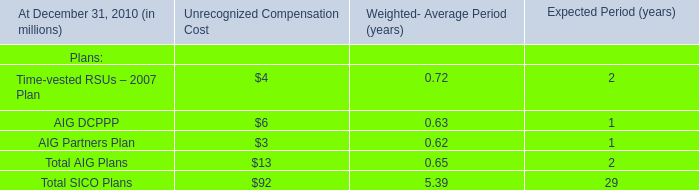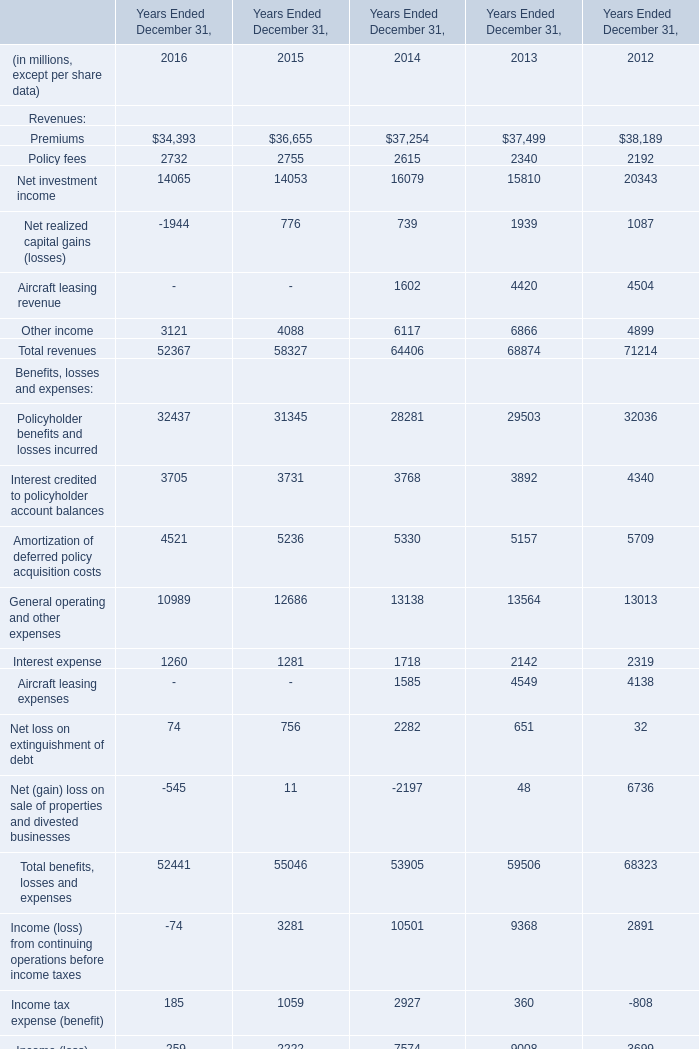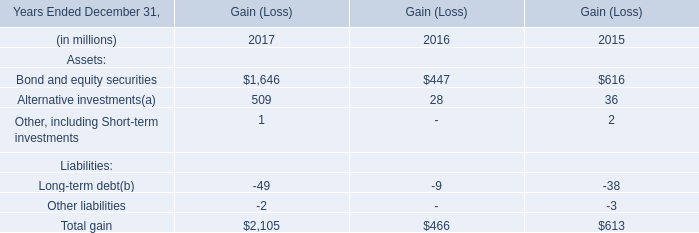What's the average of Policy fees in 2016, 2015, and 2014? (in million) 
Computations: (((2732 + 2755) + 2615) / 3)
Answer: 2700.66667. 